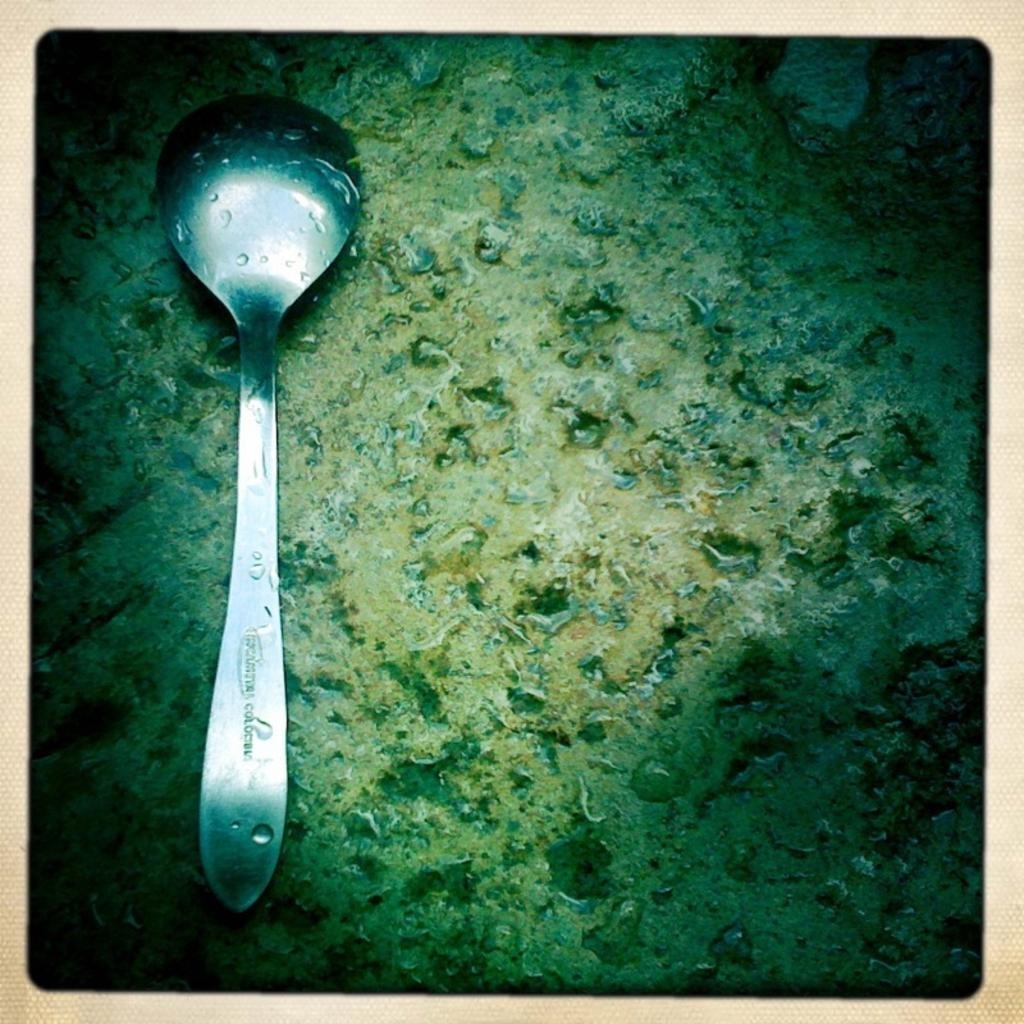What can be found in the image that contains written information? There is text in the image. What objects in the image have water droplets on them? There are water droplets on a spoon and a surface in the image. How are the borders of the image designed? The image has cream borders. What type of whip is being used to create the text in the image? There is no whip present in the image; the text is likely created using a pen, pencil, or digital means. How does the wealth of the person in the image affect the presence of water droplets? There is no person present in the image, and the wealth of an individual cannot be determined from the presence of water droplets. 